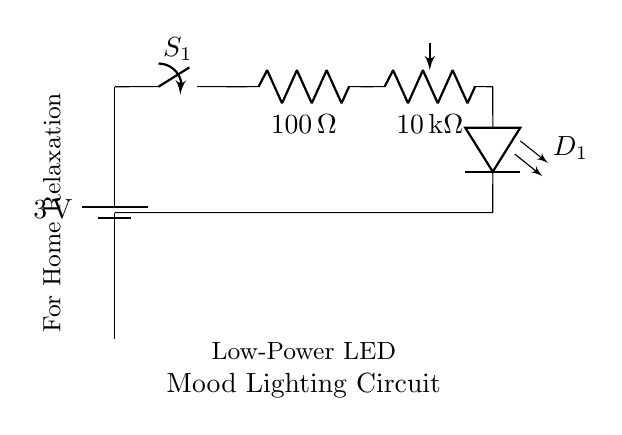What is the supply voltage of this circuit? The supply voltage is indicated by the battery symbol, which shows a value of 3 volts.
Answer: 3 volts What is the resistance value of the current limiting resistor? The current limiting resistor is labeled with a value of 100 ohms.
Answer: 100 ohms What type of component is used for brightness control? The potentiometer is used for brightness control, and it is labeled as a variable resistor with a value of 10 kilohms.
Answer: Potentiometer What components connect in series in this circuit? The components that connect in series include the battery, switch, current limiting resistor, potentiometer, and LED, as they are all part of a single path.
Answer: Battery, switch, resistor, potentiometer, LED What is the role of the LED in this circuit? The LED serves as the light-emitting element that provides mood lighting when current flows through it.
Answer: Light-emitting Why is a potentiometer used instead of a fixed resistor? A potentiometer allows for adjustable resistance, enabling the user to control the brightness of the LED, which is essential for mood lighting.
Answer: Adjust brightness 